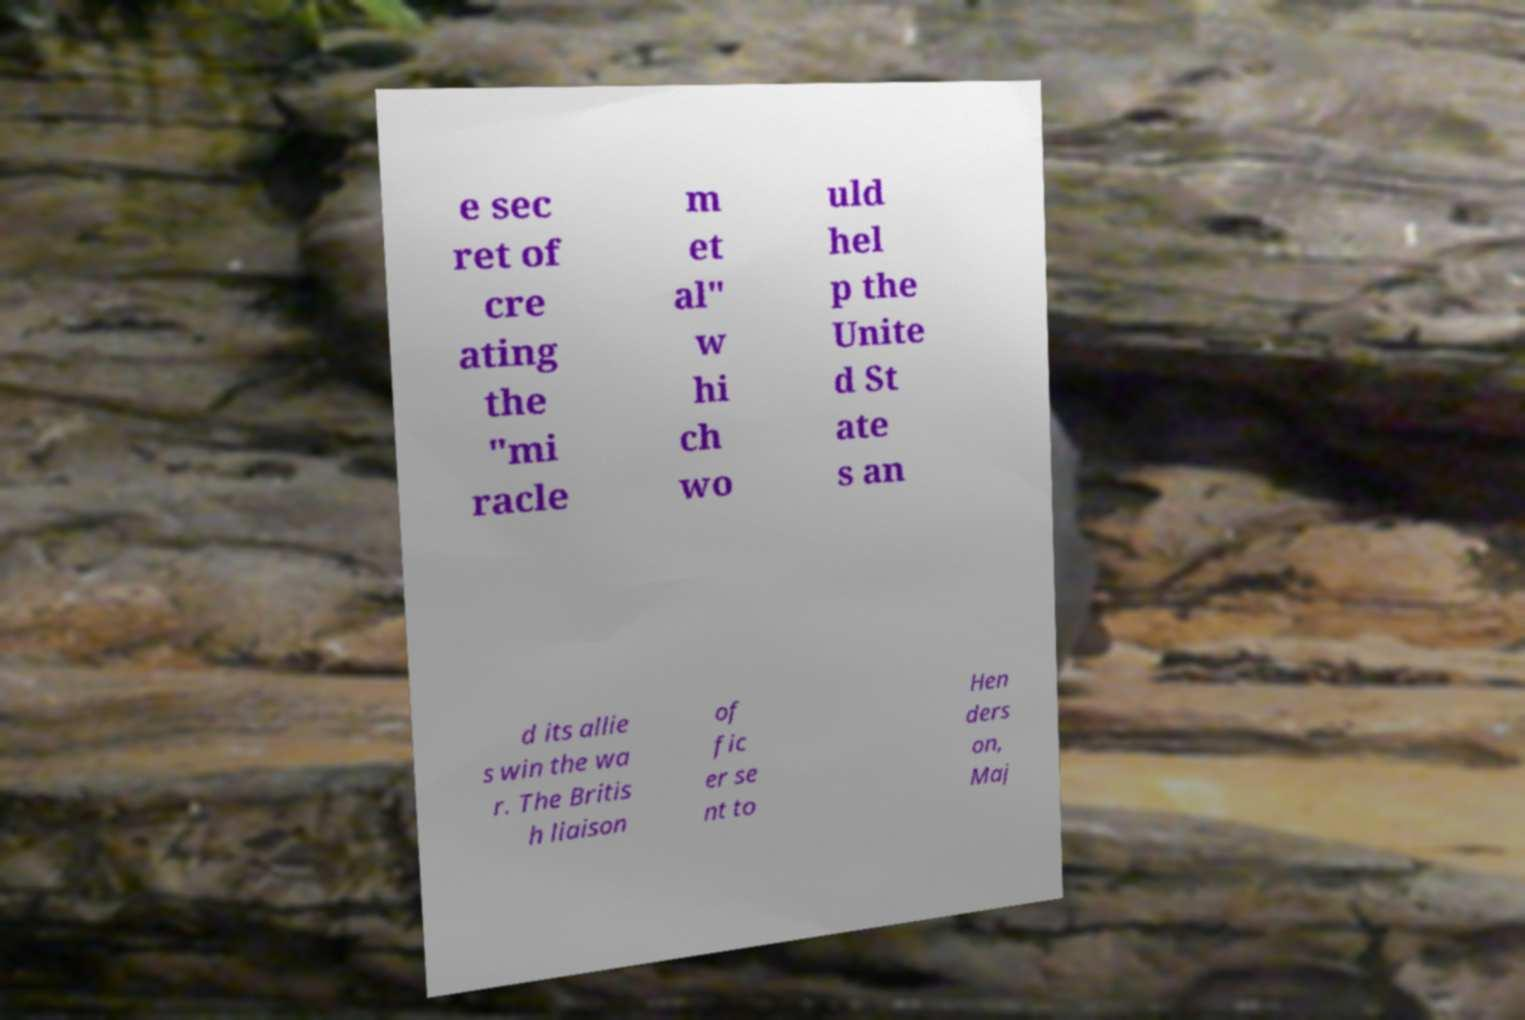Can you read and provide the text displayed in the image?This photo seems to have some interesting text. Can you extract and type it out for me? e sec ret of cre ating the "mi racle m et al" w hi ch wo uld hel p the Unite d St ate s an d its allie s win the wa r. The Britis h liaison of fic er se nt to Hen ders on, Maj 